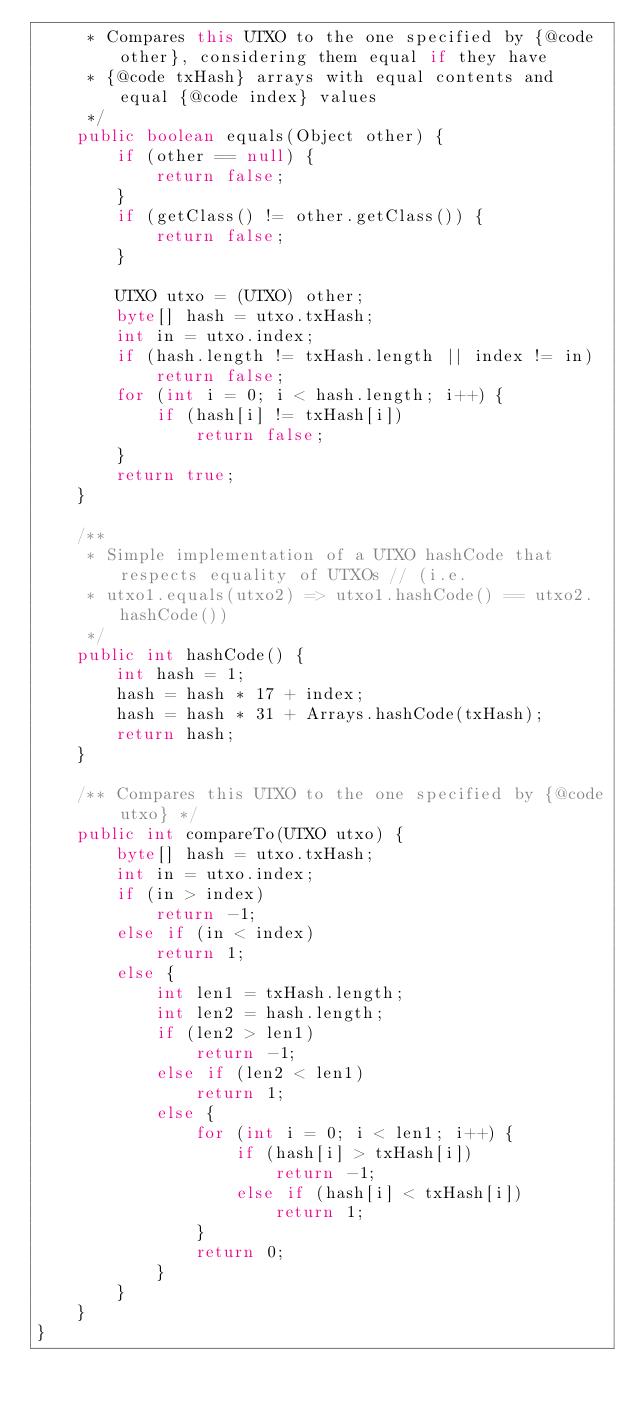<code> <loc_0><loc_0><loc_500><loc_500><_Java_>     * Compares this UTXO to the one specified by {@code other}, considering them equal if they have
     * {@code txHash} arrays with equal contents and equal {@code index} values
     */
    public boolean equals(Object other) {
        if (other == null) {
            return false;
        }
        if (getClass() != other.getClass()) {
            return false;
        }

        UTXO utxo = (UTXO) other;
        byte[] hash = utxo.txHash;
        int in = utxo.index;
        if (hash.length != txHash.length || index != in)
            return false;
        for (int i = 0; i < hash.length; i++) {
            if (hash[i] != txHash[i])
                return false;
        }
        return true;
    }

    /**
     * Simple implementation of a UTXO hashCode that respects equality of UTXOs // (i.e.
     * utxo1.equals(utxo2) => utxo1.hashCode() == utxo2.hashCode())
     */
    public int hashCode() {
        int hash = 1;
        hash = hash * 17 + index;
        hash = hash * 31 + Arrays.hashCode(txHash);
        return hash;
    }

    /** Compares this UTXO to the one specified by {@code utxo} */
    public int compareTo(UTXO utxo) {
        byte[] hash = utxo.txHash;
        int in = utxo.index;
        if (in > index)
            return -1;
        else if (in < index)
            return 1;
        else {
            int len1 = txHash.length;
            int len2 = hash.length;
            if (len2 > len1)
                return -1;
            else if (len2 < len1)
                return 1;
            else {
                for (int i = 0; i < len1; i++) {
                    if (hash[i] > txHash[i])
                        return -1;
                    else if (hash[i] < txHash[i])
                        return 1;
                }
                return 0;
            }
        }
    }
}</code> 